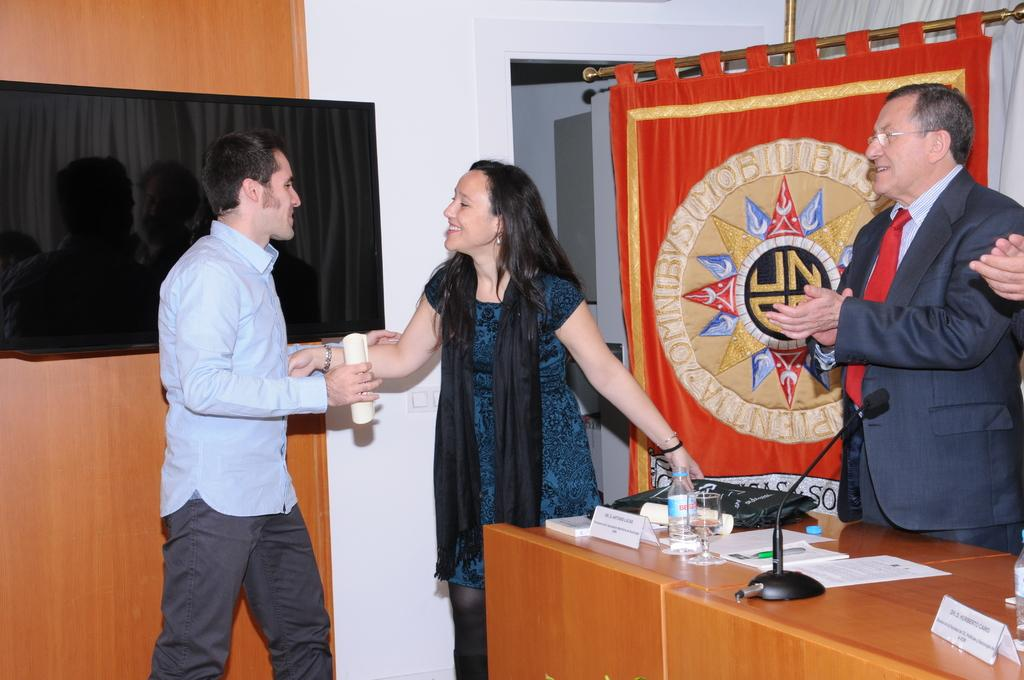How many people are present in the image? There are three people in the image. What are the two people on the right side of the image doing? A guy is shaking hands with a lady. What can be seen in the background of the image? There are red and black curtains in the background of the image. What type of fish can be seen using a calculator in the image? There is no fish or calculator present in the image. 